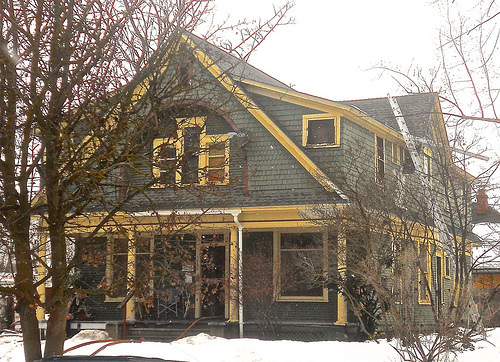<image>
Can you confirm if the tree is next to the house? Yes. The tree is positioned adjacent to the house, located nearby in the same general area. 